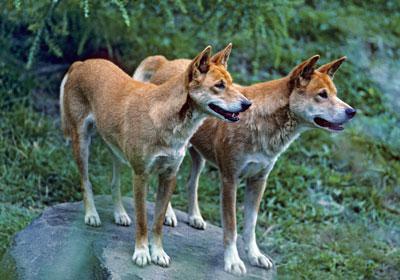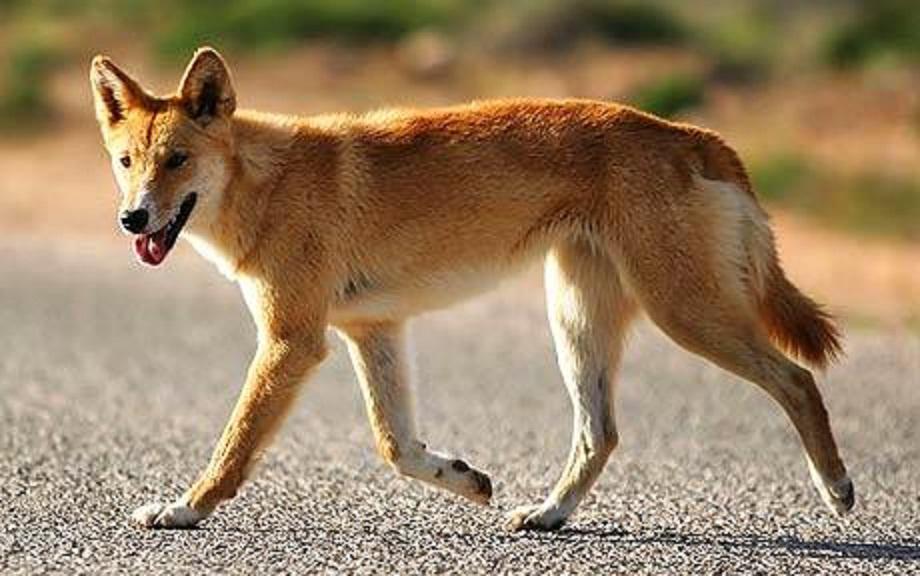The first image is the image on the left, the second image is the image on the right. Considering the images on both sides, is "There are three dogs" valid? Answer yes or no. Yes. 